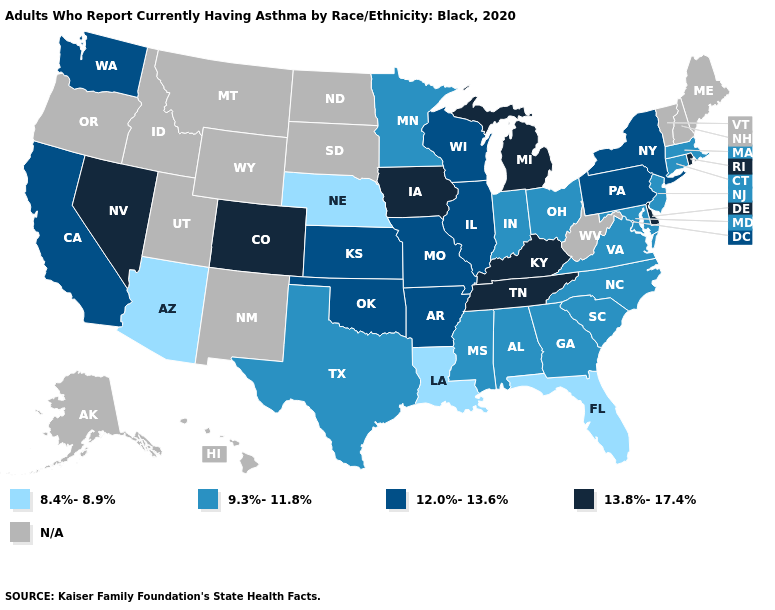What is the value of New Jersey?
Be succinct. 9.3%-11.8%. Name the states that have a value in the range 13.8%-17.4%?
Concise answer only. Colorado, Delaware, Iowa, Kentucky, Michigan, Nevada, Rhode Island, Tennessee. What is the value of Virginia?
Write a very short answer. 9.3%-11.8%. What is the value of Arkansas?
Write a very short answer. 12.0%-13.6%. Among the states that border Vermont , which have the highest value?
Be succinct. New York. What is the lowest value in states that border Kentucky?
Quick response, please. 9.3%-11.8%. Name the states that have a value in the range 8.4%-8.9%?
Answer briefly. Arizona, Florida, Louisiana, Nebraska. Name the states that have a value in the range 8.4%-8.9%?
Give a very brief answer. Arizona, Florida, Louisiana, Nebraska. What is the lowest value in the Northeast?
Keep it brief. 9.3%-11.8%. Which states have the lowest value in the USA?
Be succinct. Arizona, Florida, Louisiana, Nebraska. Name the states that have a value in the range 9.3%-11.8%?
Write a very short answer. Alabama, Connecticut, Georgia, Indiana, Maryland, Massachusetts, Minnesota, Mississippi, New Jersey, North Carolina, Ohio, South Carolina, Texas, Virginia. What is the value of California?
Quick response, please. 12.0%-13.6%. What is the highest value in the MidWest ?
Short answer required. 13.8%-17.4%. What is the value of Texas?
Give a very brief answer. 9.3%-11.8%. 